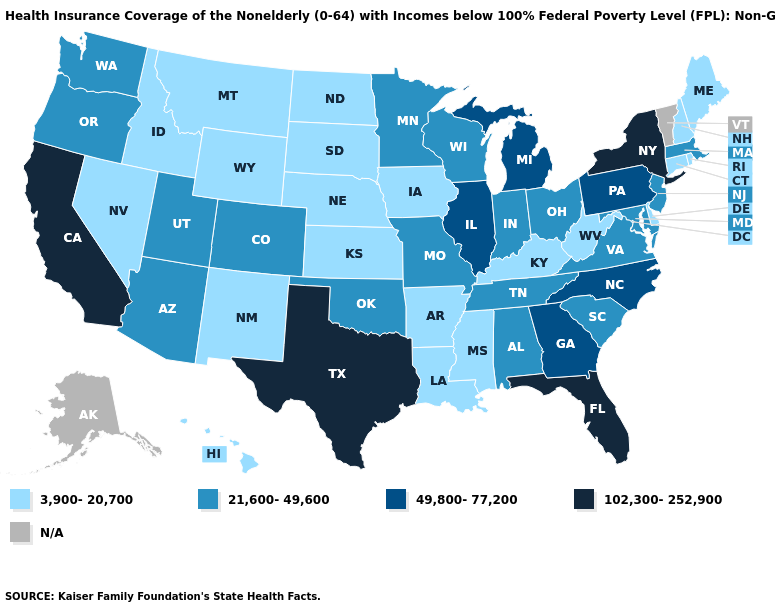Is the legend a continuous bar?
Be succinct. No. Among the states that border Arizona , does California have the lowest value?
Give a very brief answer. No. What is the value of Minnesota?
Answer briefly. 21,600-49,600. Name the states that have a value in the range 21,600-49,600?
Give a very brief answer. Alabama, Arizona, Colorado, Indiana, Maryland, Massachusetts, Minnesota, Missouri, New Jersey, Ohio, Oklahoma, Oregon, South Carolina, Tennessee, Utah, Virginia, Washington, Wisconsin. Which states have the lowest value in the Northeast?
Write a very short answer. Connecticut, Maine, New Hampshire, Rhode Island. Name the states that have a value in the range N/A?
Give a very brief answer. Alaska, Vermont. What is the value of Arizona?
Keep it brief. 21,600-49,600. Does Kentucky have the lowest value in the South?
Answer briefly. Yes. What is the value of Maryland?
Quick response, please. 21,600-49,600. What is the highest value in the Northeast ?
Short answer required. 102,300-252,900. What is the lowest value in the USA?
Quick response, please. 3,900-20,700. Does Indiana have the lowest value in the USA?
Short answer required. No. What is the value of Iowa?
Short answer required. 3,900-20,700. 